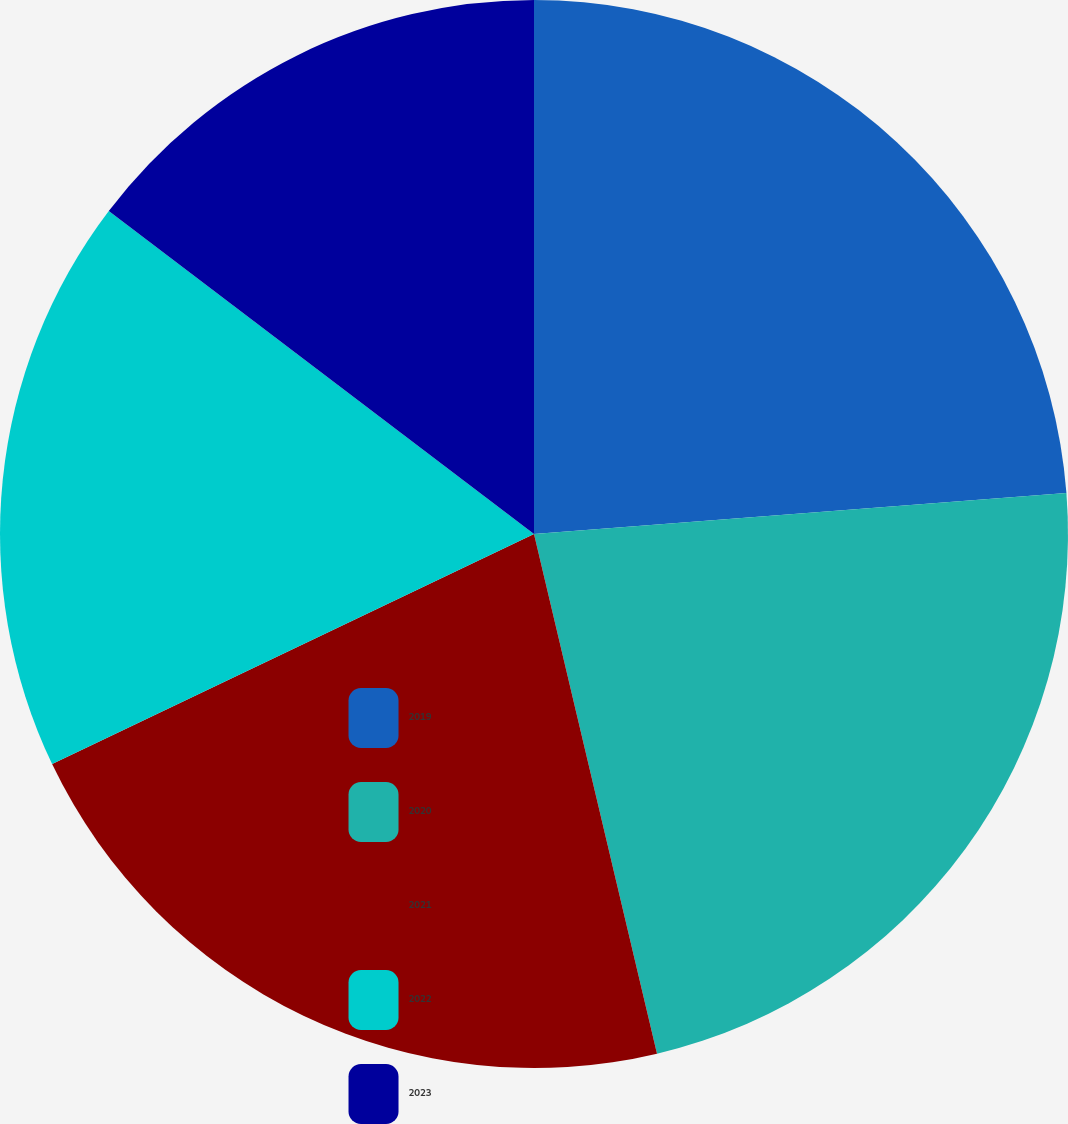Convert chart to OTSL. <chart><loc_0><loc_0><loc_500><loc_500><pie_chart><fcel>2019<fcel>2020<fcel>2021<fcel>2022<fcel>2023<nl><fcel>23.78%<fcel>22.52%<fcel>21.61%<fcel>17.43%<fcel>14.66%<nl></chart> 